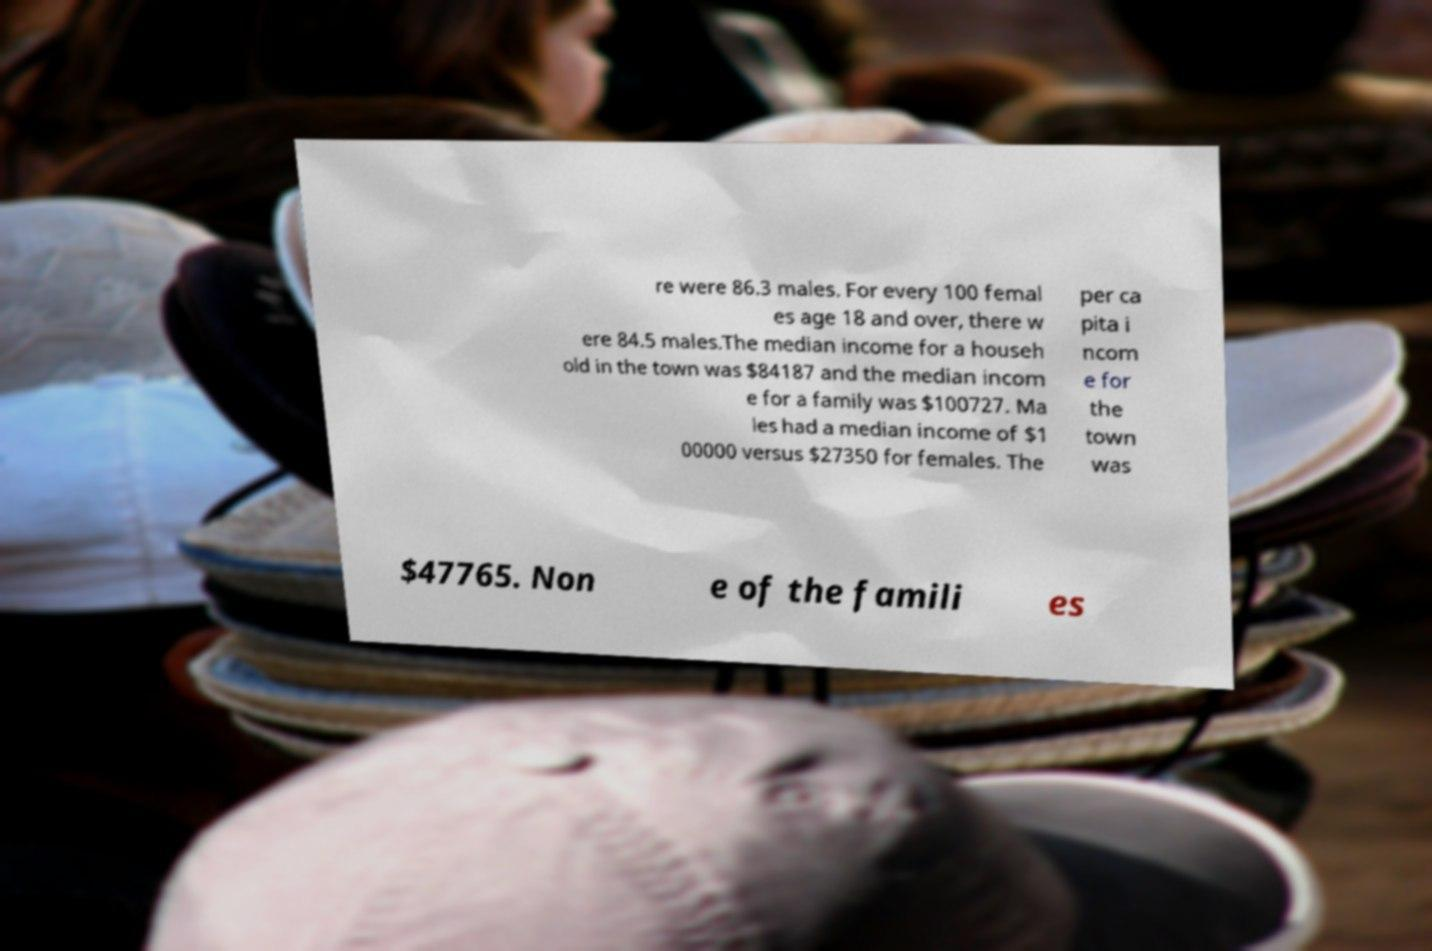Can you read and provide the text displayed in the image?This photo seems to have some interesting text. Can you extract and type it out for me? re were 86.3 males. For every 100 femal es age 18 and over, there w ere 84.5 males.The median income for a househ old in the town was $84187 and the median incom e for a family was $100727. Ma les had a median income of $1 00000 versus $27350 for females. The per ca pita i ncom e for the town was $47765. Non e of the famili es 